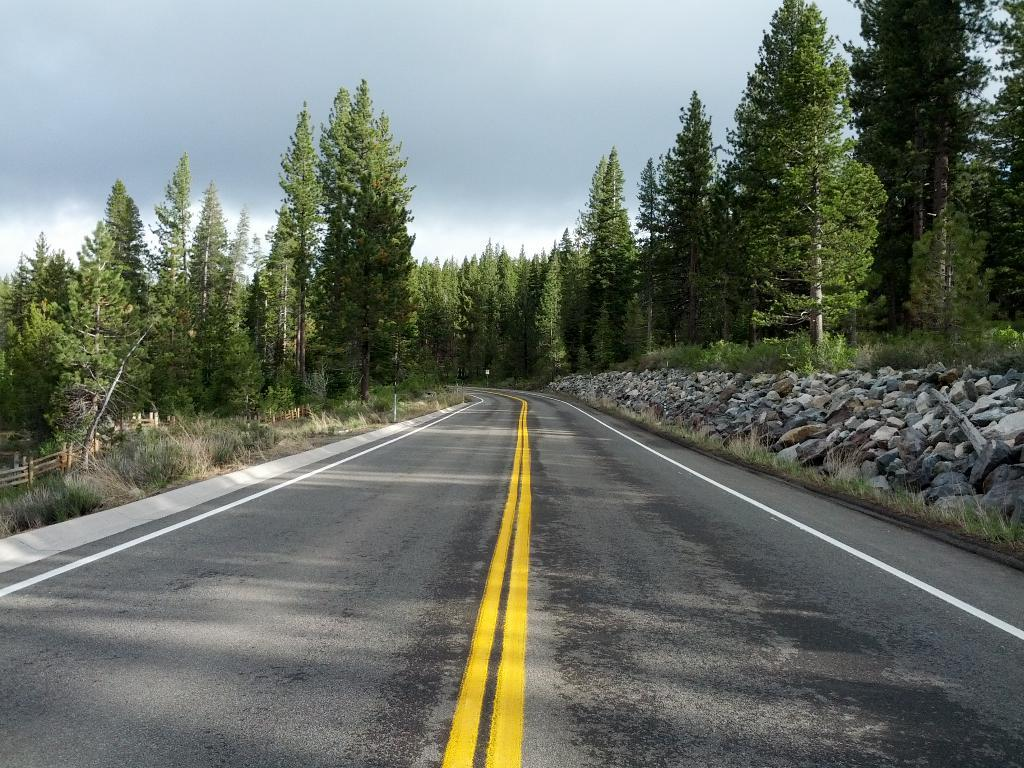What type of vegetation can be seen in the image? There are trees in the image. What type of fencing is present in the image? There is wooden fencing in the image. What type of pathway is visible in the image? The image contains a road (rd). What type of material is visible on the ground in the image? There are stones visible in the image. What part of the natural environment is visible in the image? The sky is visible in the image. What type of elbow is visible in the image? There is no elbow present in the image. What type of meal is being prepared in the image? There is no meal preparation visible in the image. 